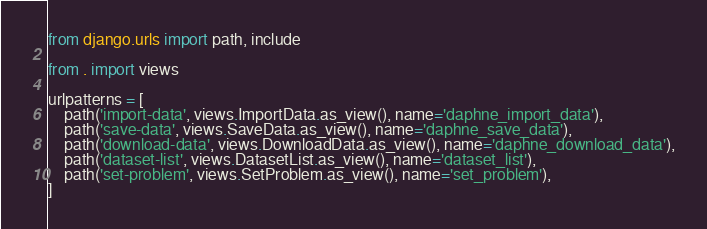<code> <loc_0><loc_0><loc_500><loc_500><_Python_>from django.urls import path, include

from . import views

urlpatterns = [
    path('import-data', views.ImportData.as_view(), name='daphne_import_data'),
    path('save-data', views.SaveData.as_view(), name='daphne_save_data'),
    path('download-data', views.DownloadData.as_view(), name='daphne_download_data'),
    path('dataset-list', views.DatasetList.as_view(), name='dataset_list'),
    path('set-problem', views.SetProblem.as_view(), name='set_problem'),
]
</code> 